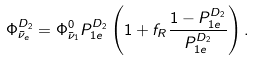<formula> <loc_0><loc_0><loc_500><loc_500>\Phi ^ { D _ { 2 } } _ { \bar { \nu } _ { e } } = \Phi ^ { 0 } _ { \bar { \nu } _ { 1 } } P ^ { D _ { 2 } } _ { 1 e } \left ( 1 + f _ { R } \frac { 1 - P ^ { D _ { 2 } } _ { 1 e } } { P ^ { D _ { 2 } } _ { 1 e } } \right ) .</formula> 